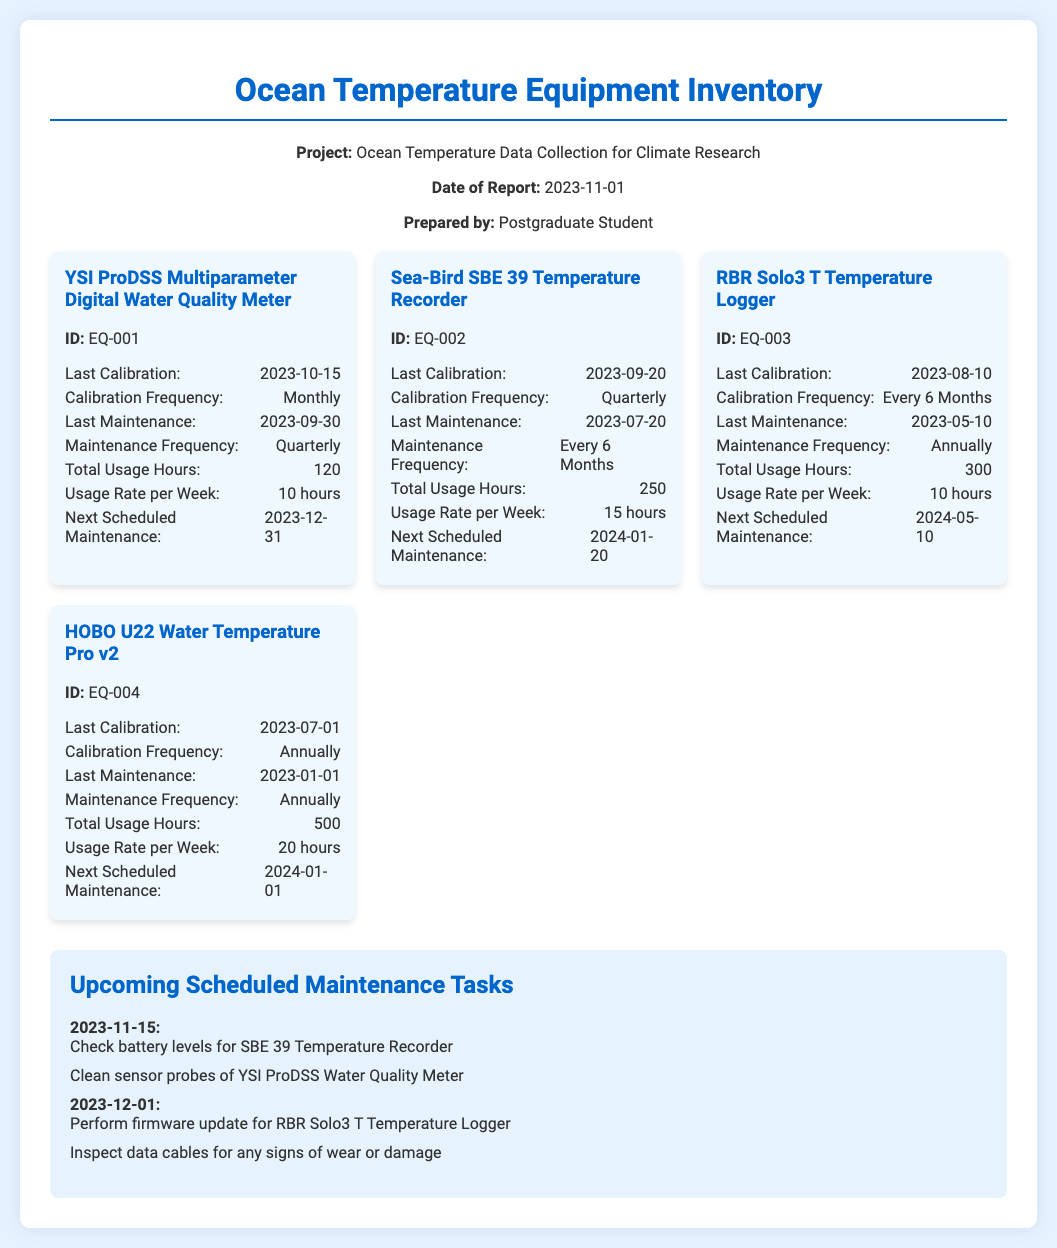what is the title of the document? The title of the document is stated at the top and describes the content of the report.
Answer: Ocean Temperature Equipment Inventory when was the last calibration of the YSI ProDSS Meter? The last calibration date for the YSI ProDSS Meter is specified in the equipment card section.
Answer: 2023-10-15 what is the maintenance frequency for the Sea-Bird SBE 39 Temperature Recorder? The maintenance frequency is listed under the equipment card details for the Sea-Bird SBE 39 Temperature Recorder.
Answer: Every 6 Months how many total usage hours does the HOBO U22 Water Temperature Pro v2 have? The total usage hours for the HOBO U22 Water Temperature Pro v2 are specifically mentioned in its equipment card.
Answer: 500 when is the next scheduled maintenance for the RBR Solo3 T Temperature Logger? The next scheduled maintenance date for the RBR Solo3 T is detailed in its maintenance section.
Answer: 2024-05-10 what task is scheduled for November 15, 2023? The scheduled task includes specific actions listed under the upcoming tasks for that date.
Answer: Check battery levels for SBE 39 Temperature Recorder which equipment has the highest total usage hours? The comparison of total usage hours is made easier by reviewing the total hours in each equipment card.
Answer: HOBO U22 Water Temperature Pro v2 what type of report is this document? The type of report is indicated in the header information section of the document.
Answer: Equipment Inventory and Maintenance Log 